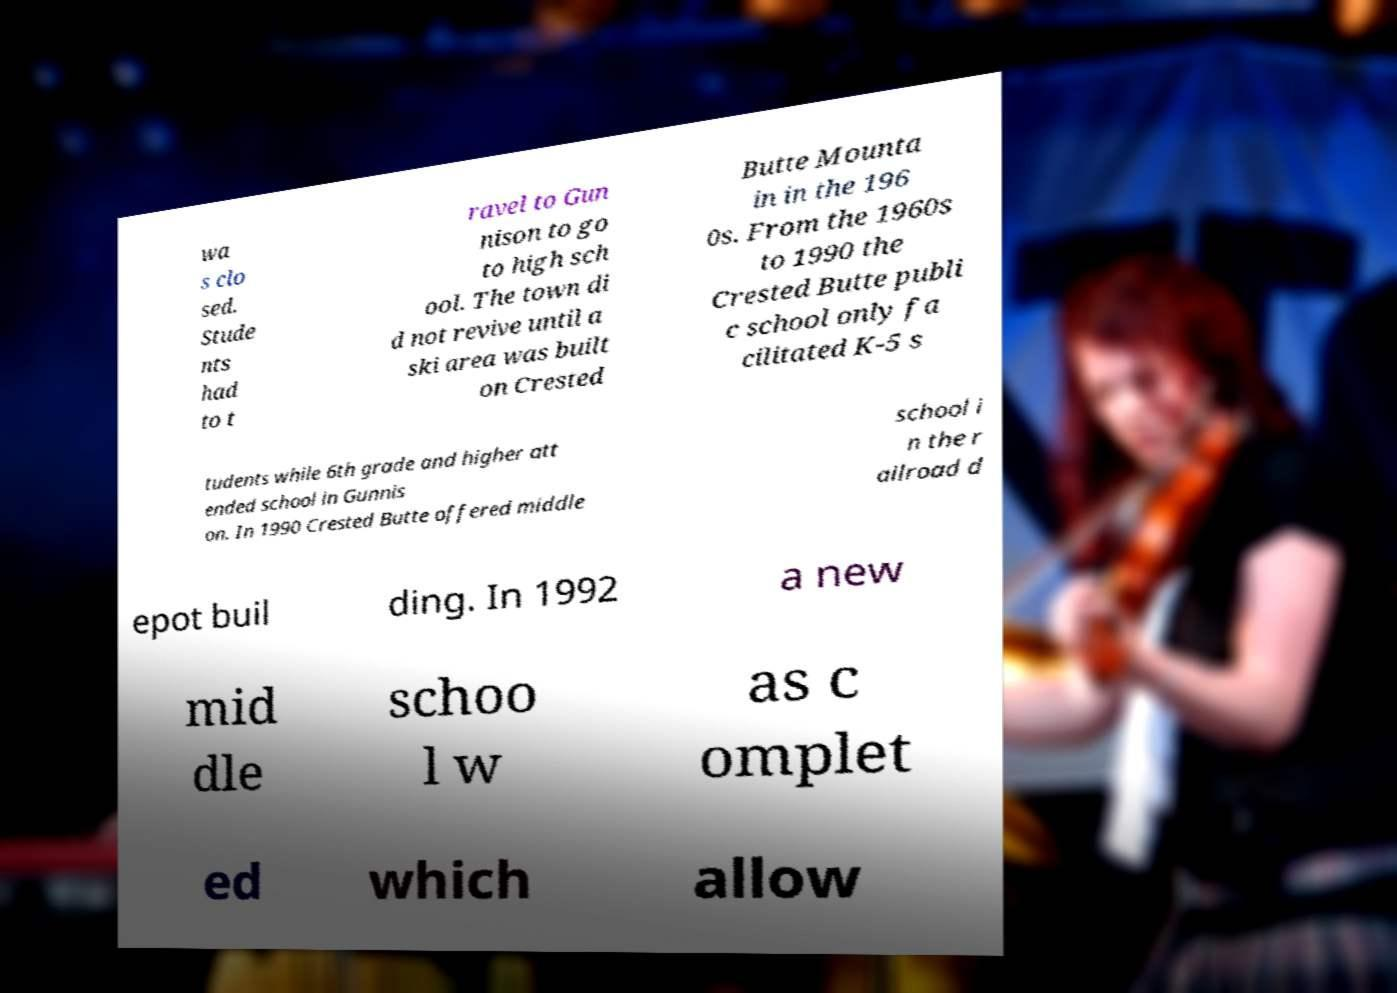Can you read and provide the text displayed in the image?This photo seems to have some interesting text. Can you extract and type it out for me? wa s clo sed. Stude nts had to t ravel to Gun nison to go to high sch ool. The town di d not revive until a ski area was built on Crested Butte Mounta in in the 196 0s. From the 1960s to 1990 the Crested Butte publi c school only fa cilitated K-5 s tudents while 6th grade and higher att ended school in Gunnis on. In 1990 Crested Butte offered middle school i n the r ailroad d epot buil ding. In 1992 a new mid dle schoo l w as c omplet ed which allow 